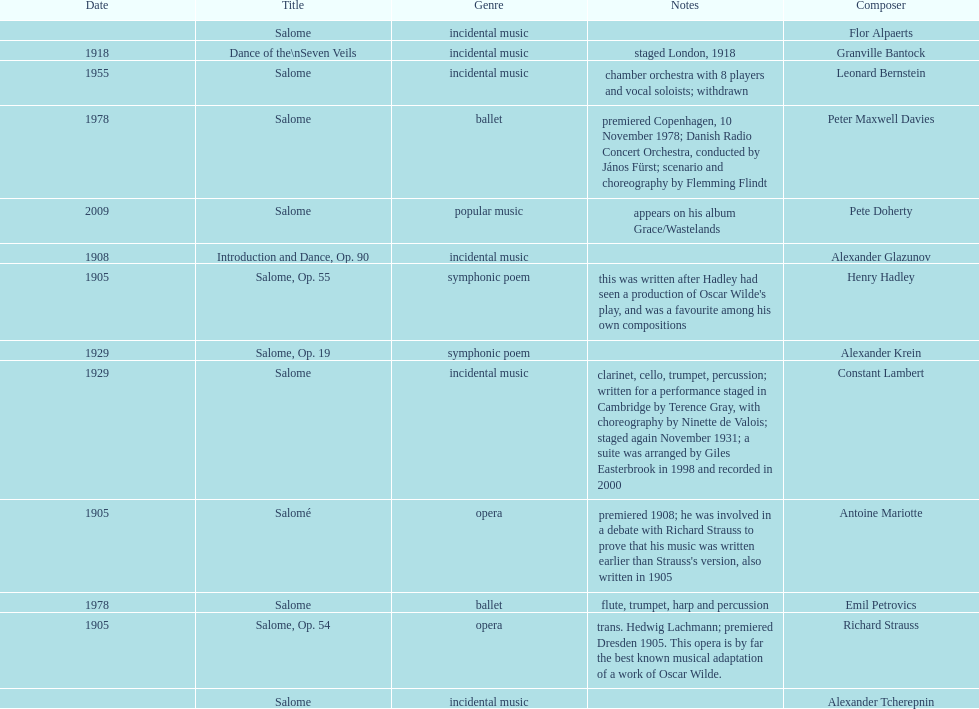How many are symphonic poems? 2. 